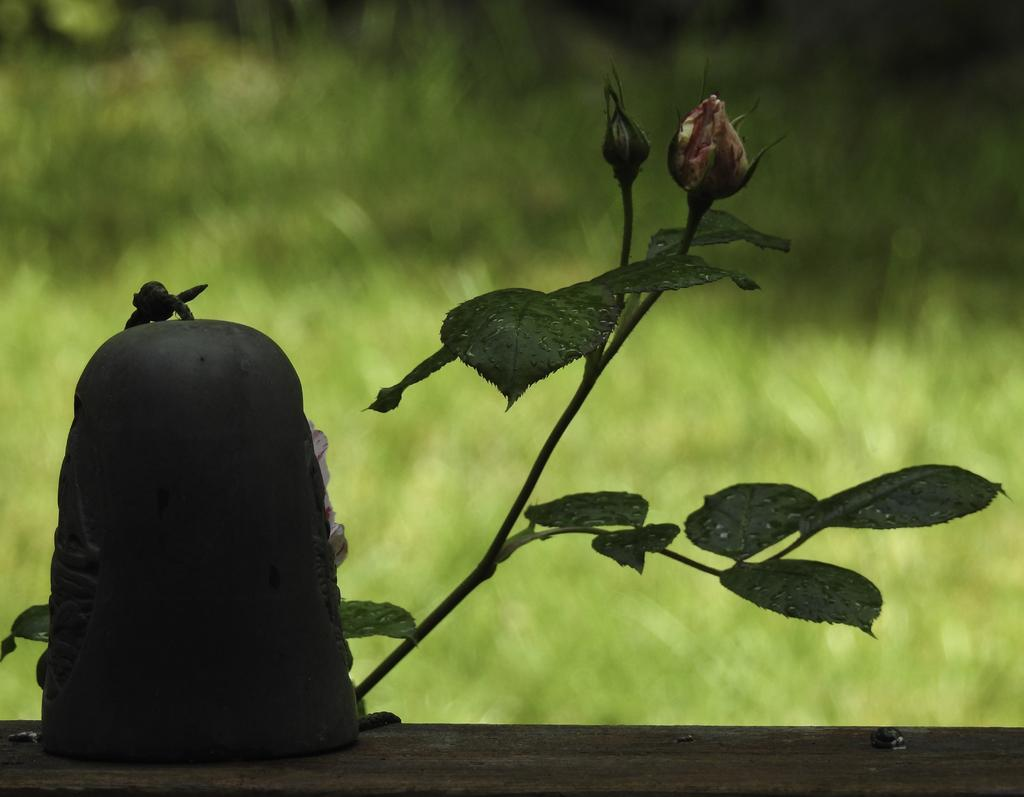What type of plant is in the image? There is a rose plant in the image. What stage of growth are the flowers on the rose plant in? The rose plant has buds. What type of sound can be heard coming from the rose plant in the image? There is no sound coming from the rose plant in the image. 